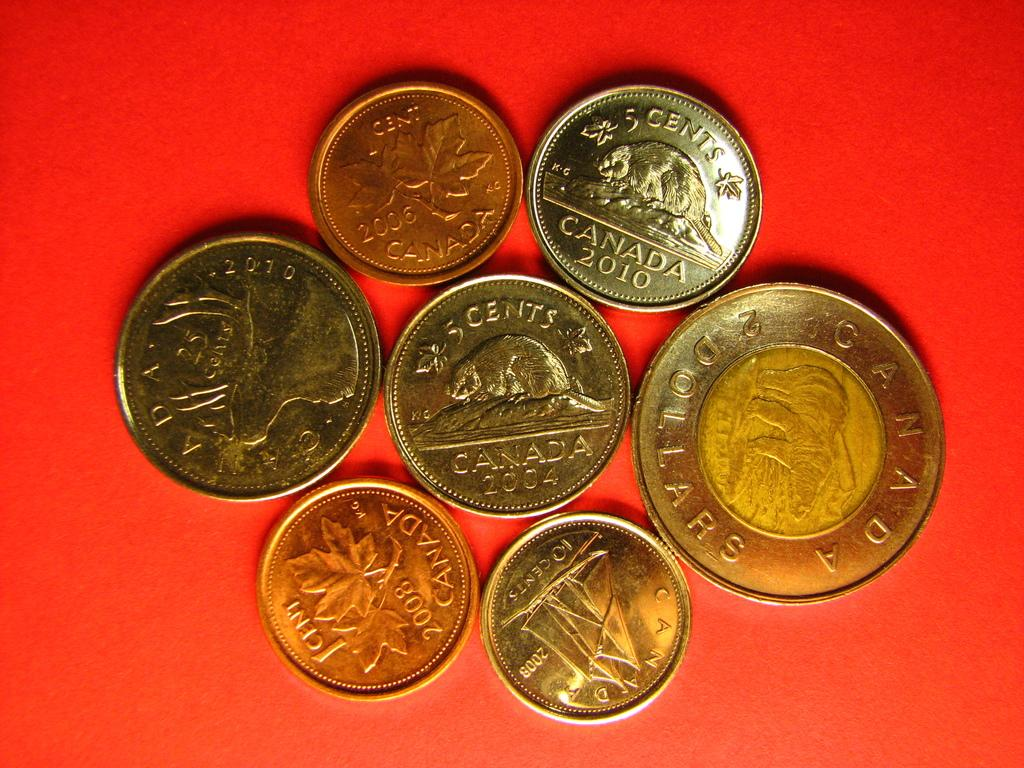<image>
Offer a succinct explanation of the picture presented. Multiple gold coins on a table that says "2008" on one of them. 